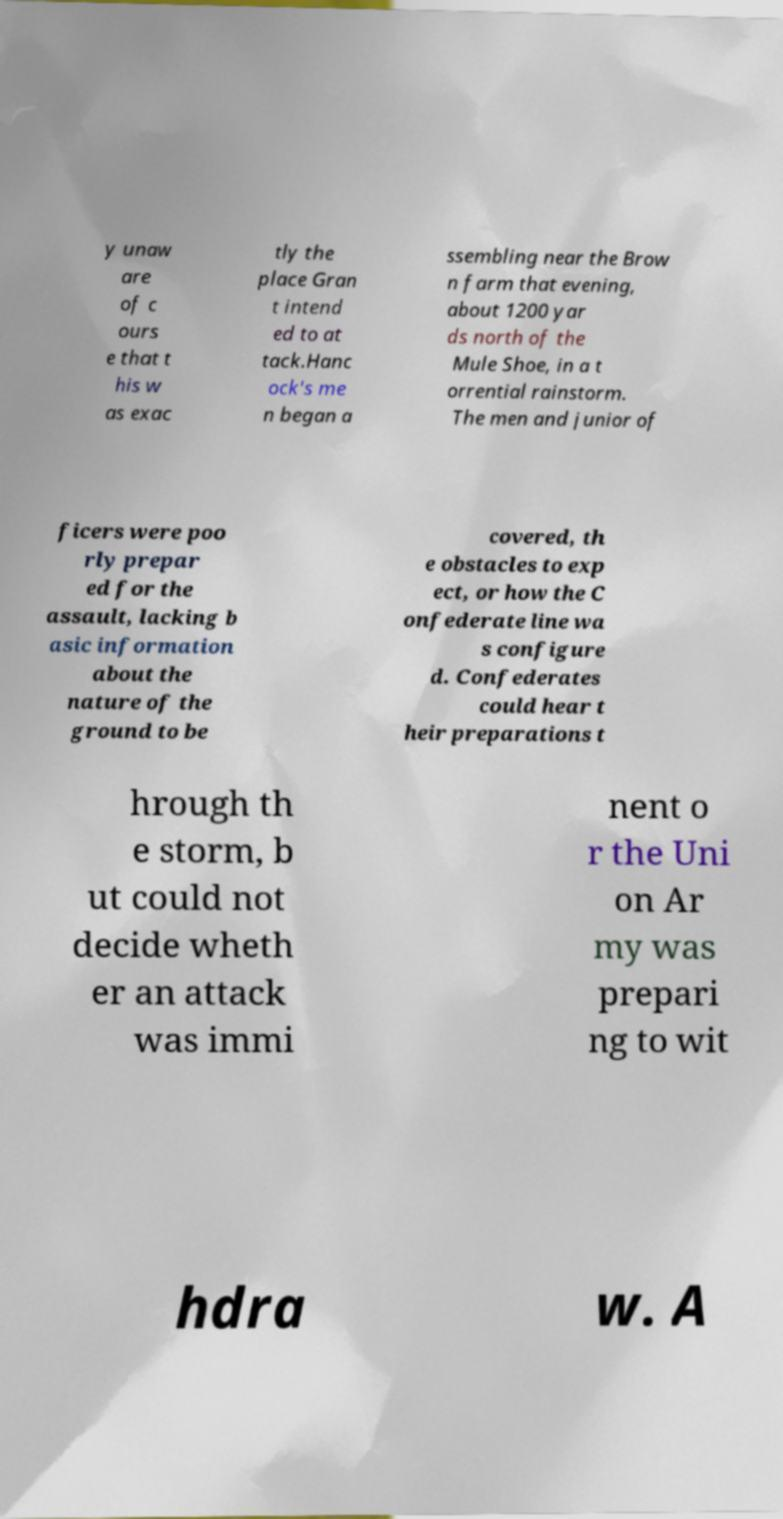Please identify and transcribe the text found in this image. y unaw are of c ours e that t his w as exac tly the place Gran t intend ed to at tack.Hanc ock's me n began a ssembling near the Brow n farm that evening, about 1200 yar ds north of the Mule Shoe, in a t orrential rainstorm. The men and junior of ficers were poo rly prepar ed for the assault, lacking b asic information about the nature of the ground to be covered, th e obstacles to exp ect, or how the C onfederate line wa s configure d. Confederates could hear t heir preparations t hrough th e storm, b ut could not decide wheth er an attack was immi nent o r the Uni on Ar my was prepari ng to wit hdra w. A 